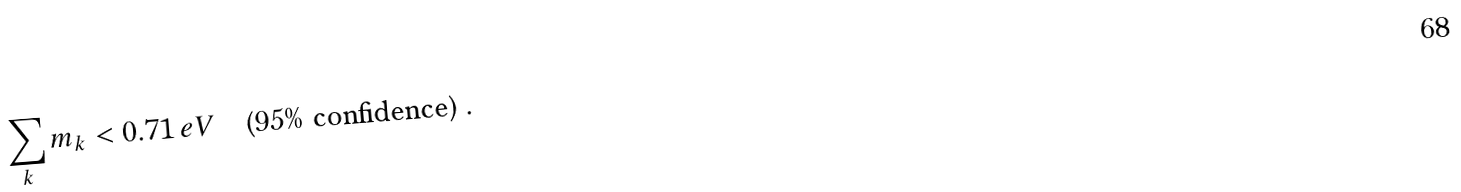<formula> <loc_0><loc_0><loc_500><loc_500>\sum _ { k } m _ { k } < 0 . 7 1 \, e V \quad \text {(95\% confidence)} \, .</formula> 